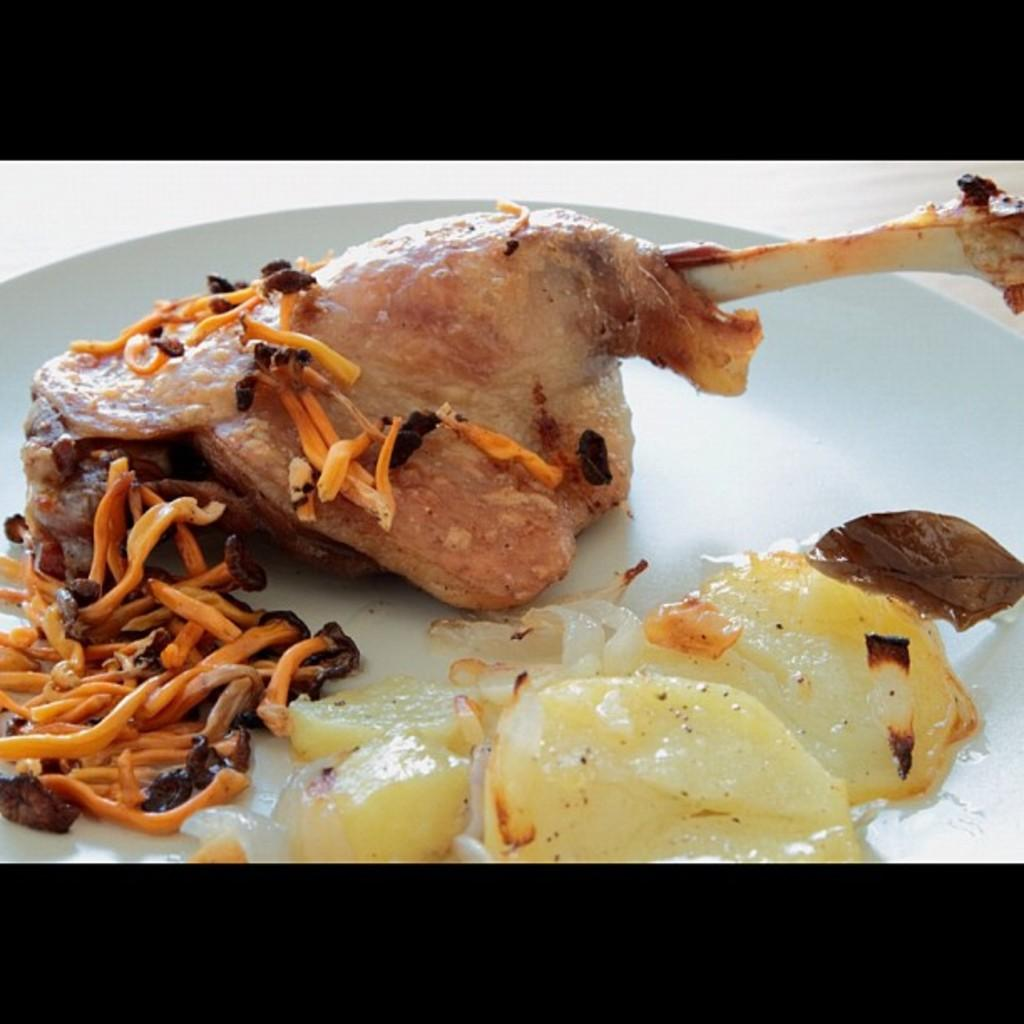What object is present in the image that typically holds food? There is a plate in the image. What can be found on the plate? There is food on the plate. What type of fuel is being used to power the food on the plate? There is no fuel present in the image, as the food on the plate is not a source of power or energy. 